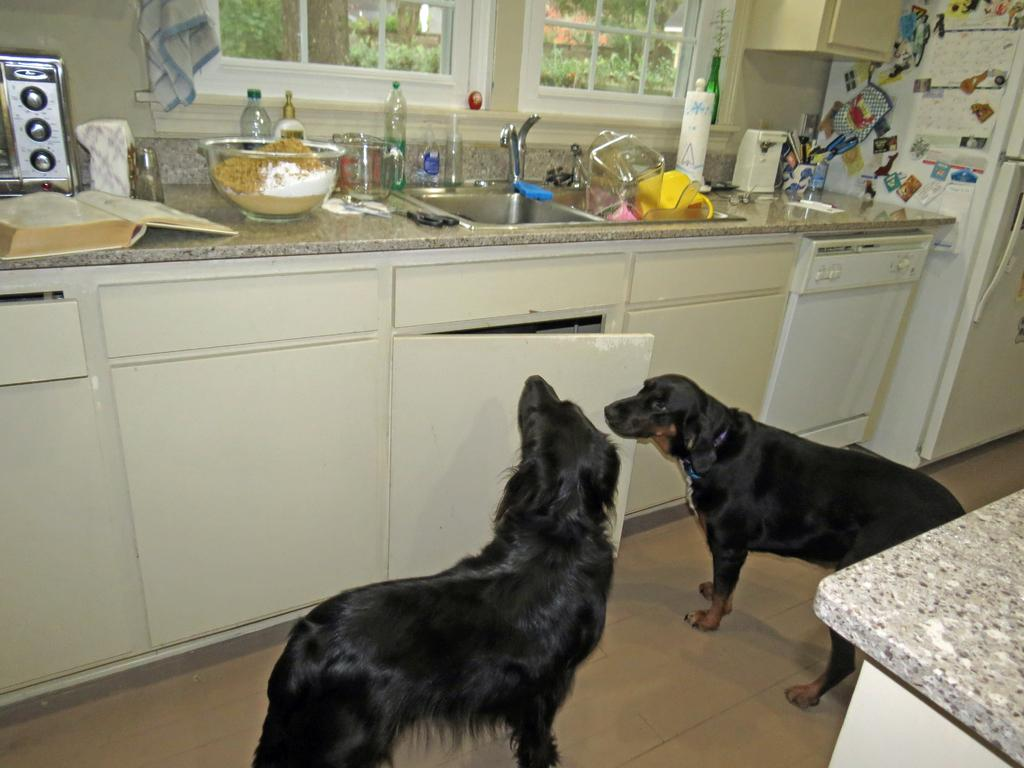How many dogs are in the image? There are two black dogs in the image. Where are the dogs located in the image? The dogs are standing on the floor. What type of area is in the background of the image? The floor is in front of a kitchen area. What appliances or fixtures can be seen in the kitchen area? There is a sink, utensils, an oven, and bottles visible in the kitchen area. Is there any natural light source in the image? Yes, there is a window in front of the kitchen area. How do the dogs show respect to the deer in the image? There are no deer present in the image, so the dogs cannot show respect to them. 